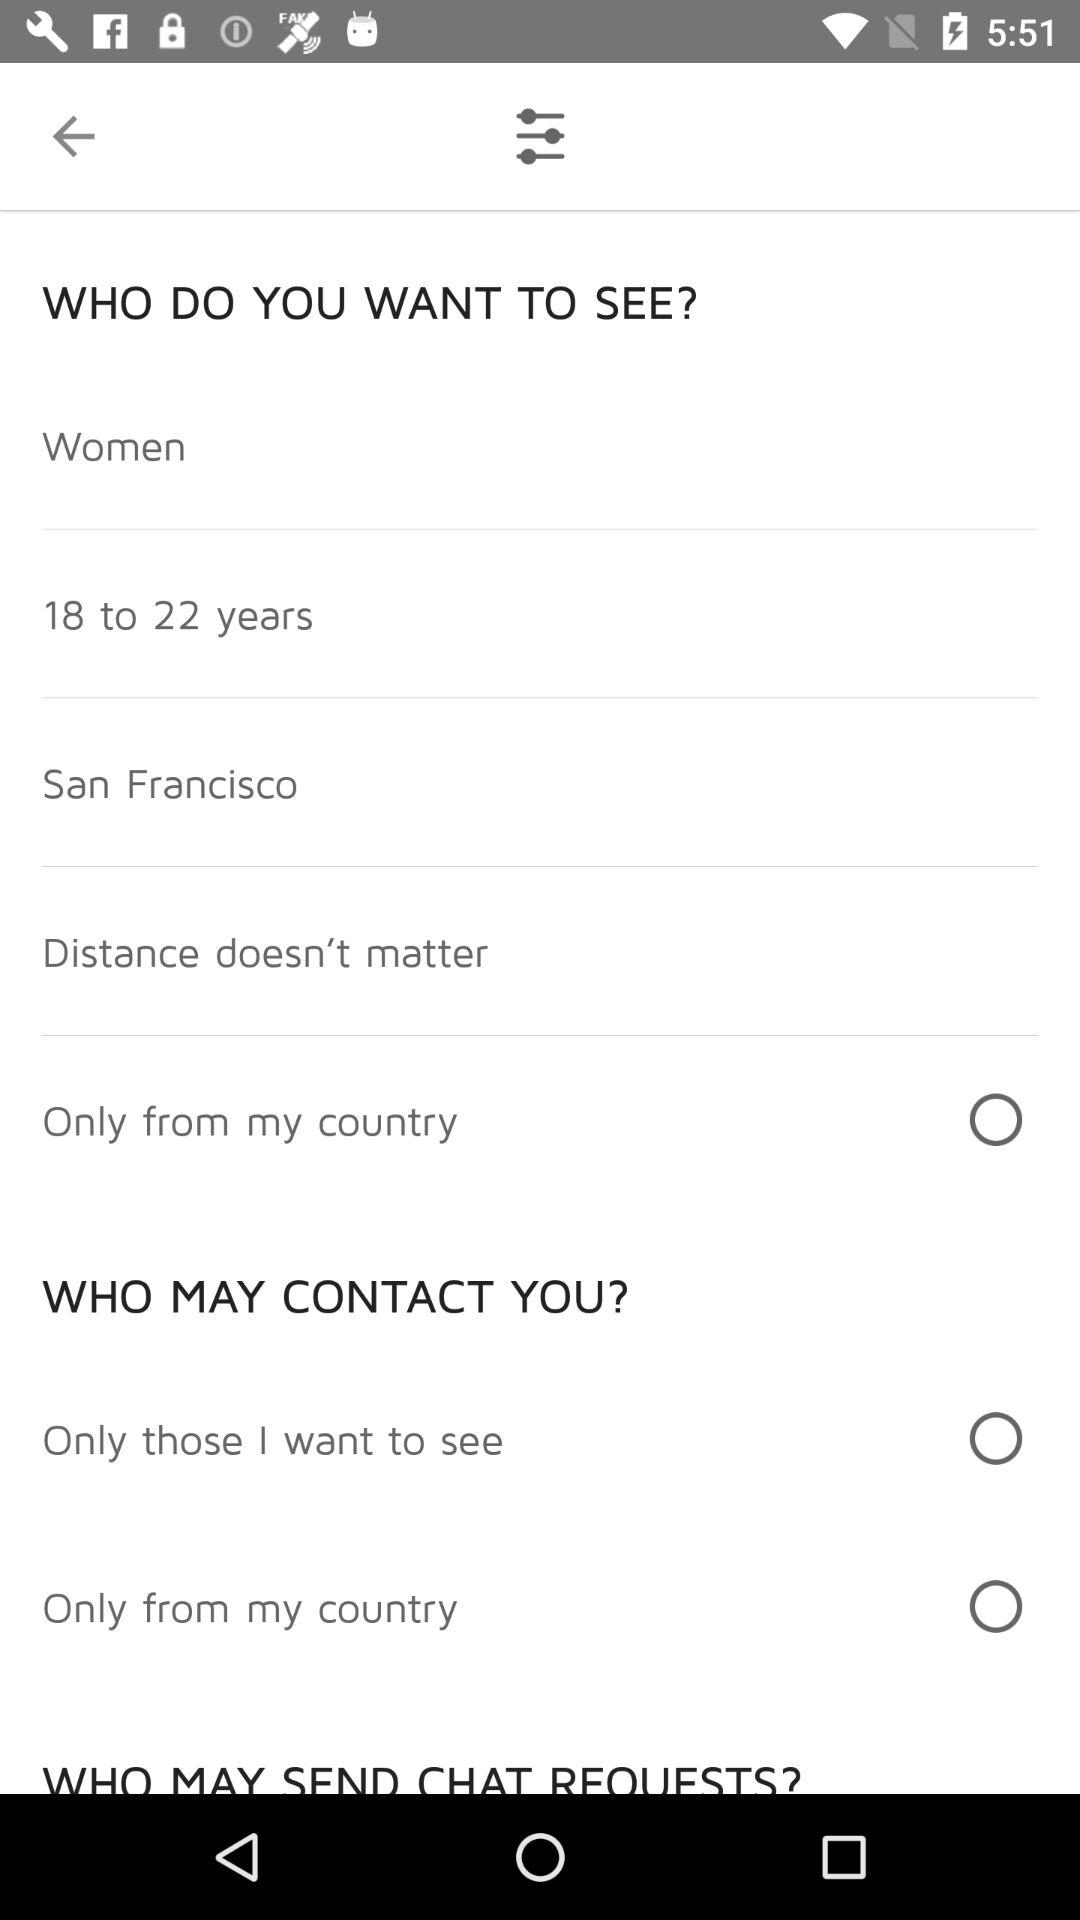What is the name of the city? The name of the city is San Francisco. 